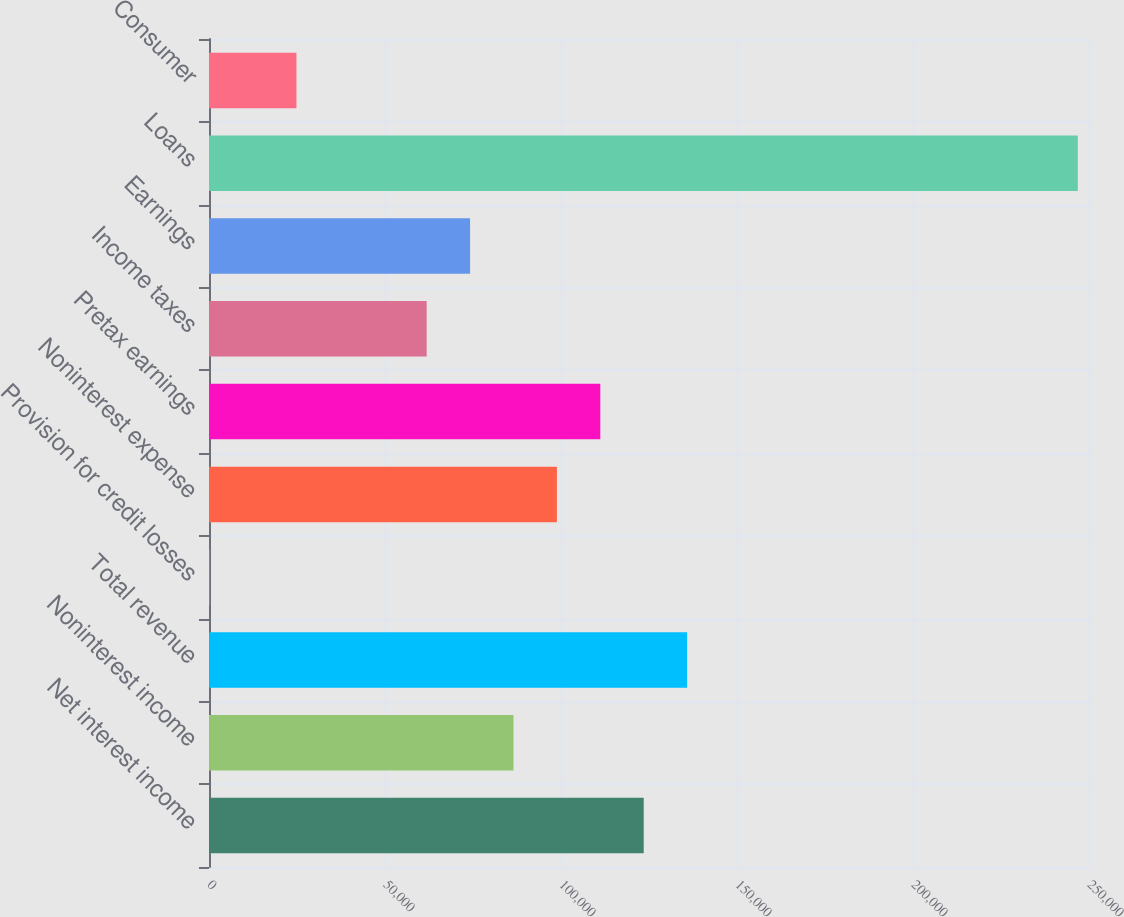Convert chart to OTSL. <chart><loc_0><loc_0><loc_500><loc_500><bar_chart><fcel>Net interest income<fcel>Noninterest income<fcel>Total revenue<fcel>Provision for credit losses<fcel>Noninterest expense<fcel>Pretax earnings<fcel>Income taxes<fcel>Earnings<fcel>Loans<fcel>Consumer<nl><fcel>123498<fcel>86501.7<fcel>135830<fcel>177<fcel>98833.8<fcel>111166<fcel>61837.5<fcel>74169.6<fcel>246819<fcel>24841.2<nl></chart> 